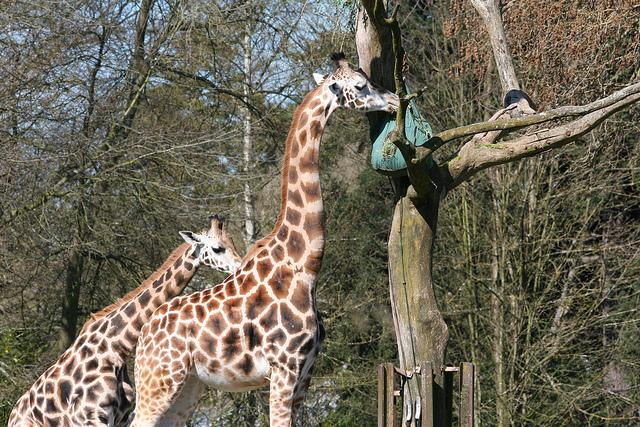What distinguishes the animals above from the rest? Please explain your reasoning. tallest. Giraffes are shown and are taller than most other animals. 